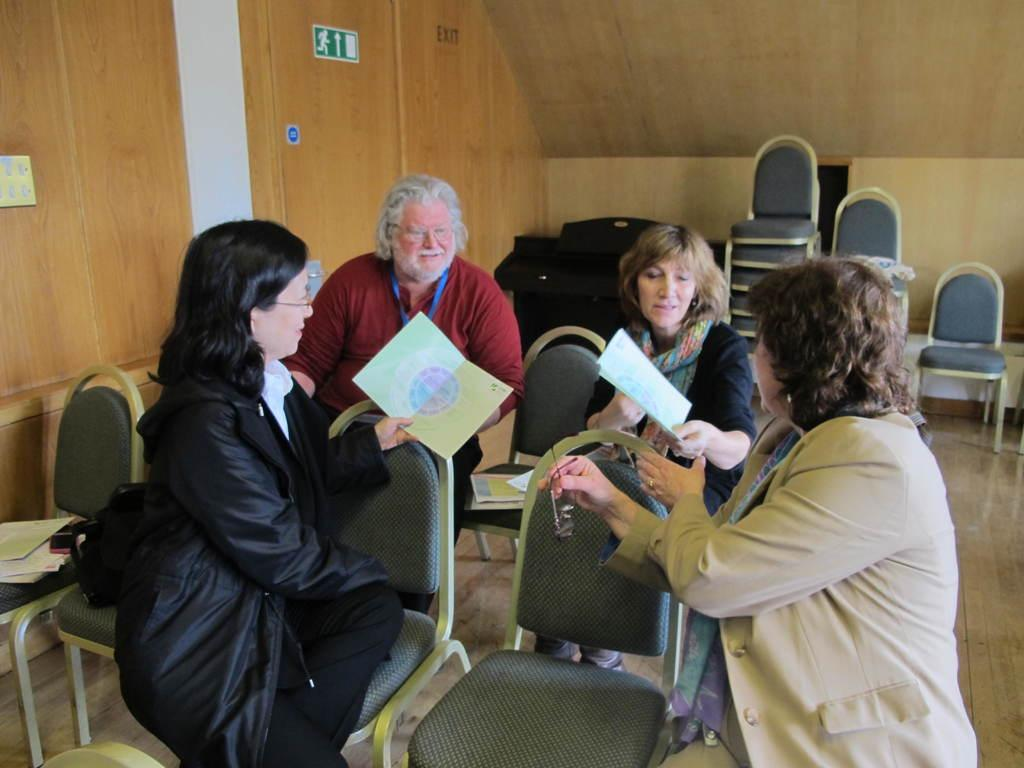How many people are in the image? There are four persons in the image. What are the persons doing in the image? The four persons are sitting in chairs. What are two of the persons holding in their hands? Two of the persons are holding green color sheets in their hands. What type of trucks can be seen in the image? There are no trucks present in the image. What subject is being taught by the persons in the image? The image does not depict any teaching or educational activity, so it cannot be determined what subject is being taught. 